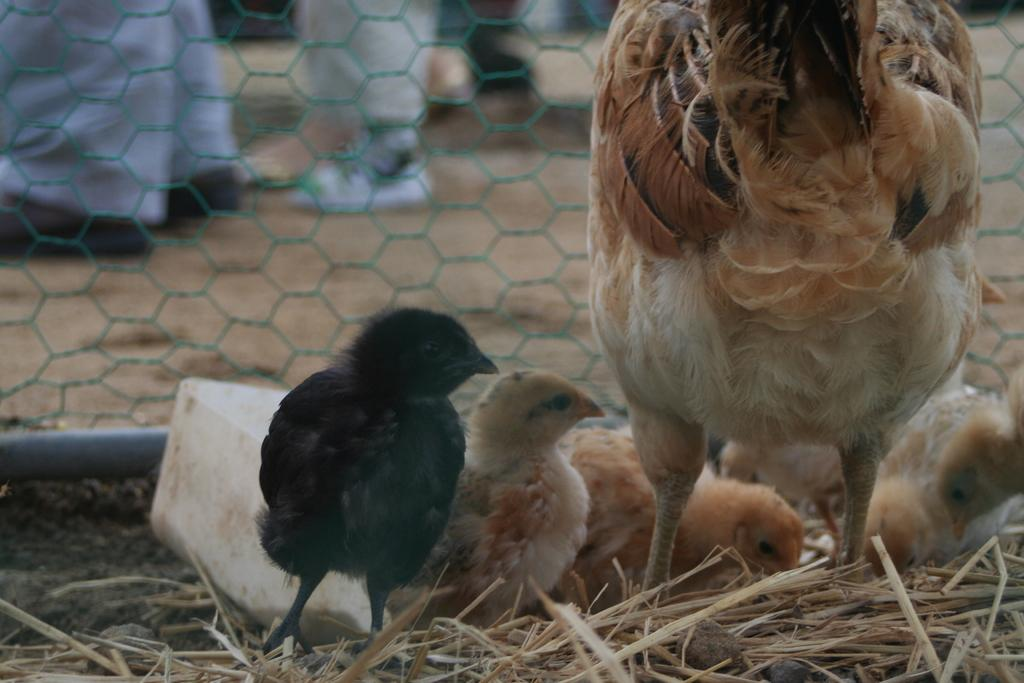What type of animals are in the image? There are chicks and a hen in the image. Where are the chicks and hen located? They are on the grass in the image. What else can be seen in the image? There is a mesh visible in the image. What is behind the mesh? There are legs of people visible behind the mesh. What type of servant can be seen attending to the chicks in the image? There is no servant present in the image; it only features chicks, a hen, grass, a mesh, and people's legs behind the mesh. 